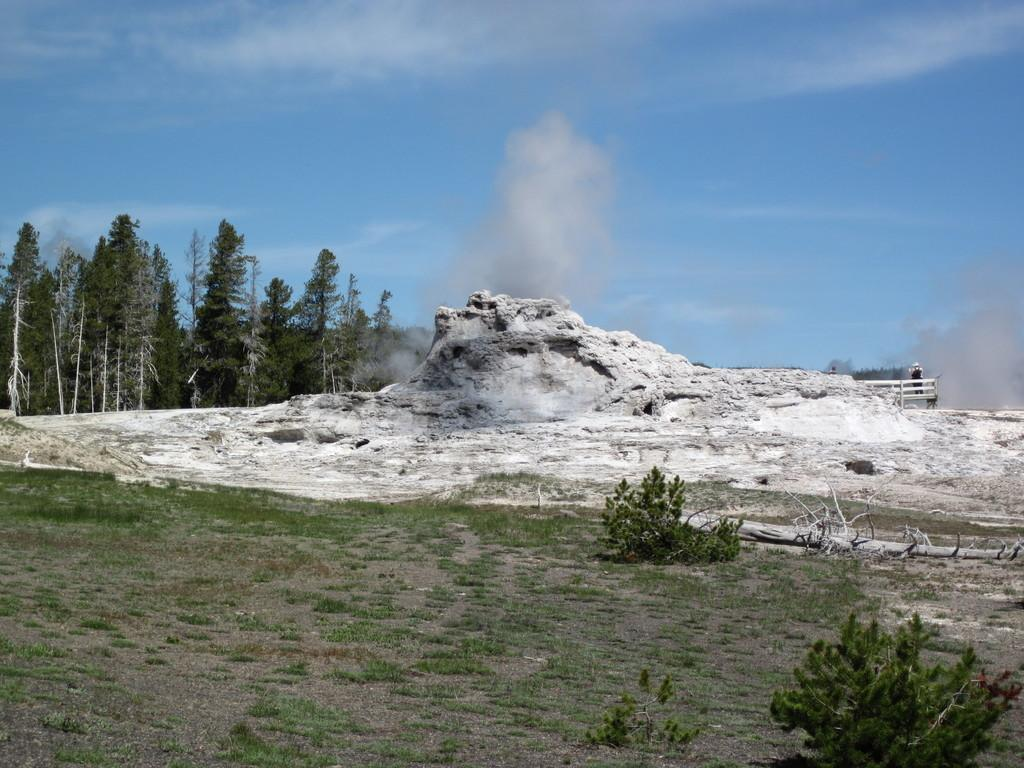What is the main feature of the image? There is a white mountain in the image. What type of vegetation can be seen in the image? Trees are present at the back of the image. How many facts can be seen on the neck of the person in the image? There is no person present in the image, and therefore no neck or facts to be seen. 